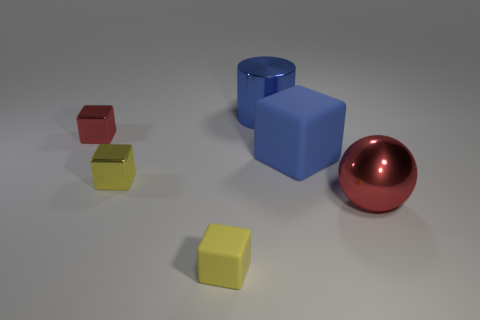Subtract all big blocks. How many blocks are left? 3 Add 1 big red metallic spheres. How many objects exist? 7 Subtract all yellow blocks. How many blocks are left? 2 Subtract 1 balls. How many balls are left? 0 Add 5 red metal things. How many red metal things are left? 7 Add 5 yellow metal cubes. How many yellow metal cubes exist? 6 Subtract 0 green cubes. How many objects are left? 6 Subtract all cylinders. How many objects are left? 5 Subtract all green blocks. Subtract all yellow spheres. How many blocks are left? 4 Subtract all cyan balls. How many yellow cubes are left? 2 